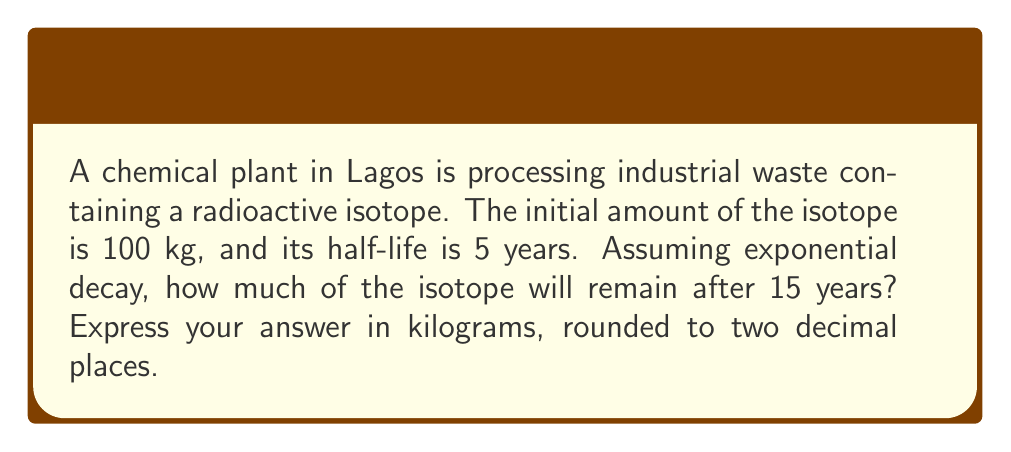Give your solution to this math problem. To solve this problem, we'll use the exponential decay formula:

$$A(t) = A_0 \cdot (1/2)^{t/t_{1/2}}$$

Where:
$A(t)$ is the amount remaining after time $t$
$A_0$ is the initial amount
$t$ is the time elapsed
$t_{1/2}$ is the half-life

Given:
$A_0 = 100$ kg
$t = 15$ years
$t_{1/2} = 5$ years

Step 1: Substitute the values into the formula
$$A(15) = 100 \cdot (1/2)^{15/5}$$

Step 2: Simplify the exponent
$$A(15) = 100 \cdot (1/2)^3$$

Step 3: Calculate the result
$$A(15) = 100 \cdot (1/8) = 12.5$$

Therefore, after 15 years, 12.5 kg of the radioactive isotope will remain.
Answer: 12.50 kg 